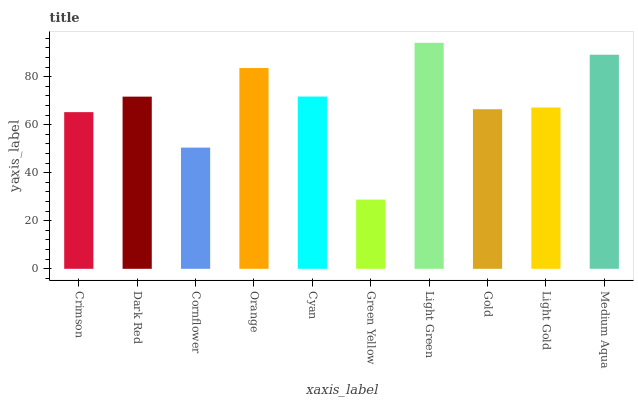Is Green Yellow the minimum?
Answer yes or no. Yes. Is Light Green the maximum?
Answer yes or no. Yes. Is Dark Red the minimum?
Answer yes or no. No. Is Dark Red the maximum?
Answer yes or no. No. Is Dark Red greater than Crimson?
Answer yes or no. Yes. Is Crimson less than Dark Red?
Answer yes or no. Yes. Is Crimson greater than Dark Red?
Answer yes or no. No. Is Dark Red less than Crimson?
Answer yes or no. No. Is Dark Red the high median?
Answer yes or no. Yes. Is Light Gold the low median?
Answer yes or no. Yes. Is Crimson the high median?
Answer yes or no. No. Is Light Green the low median?
Answer yes or no. No. 